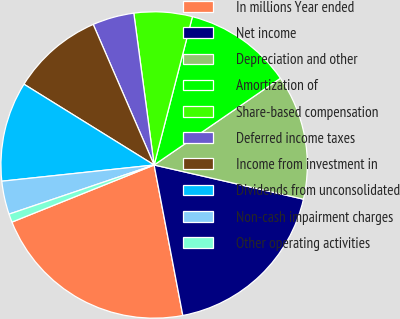Convert chart. <chart><loc_0><loc_0><loc_500><loc_500><pie_chart><fcel>In millions Year ended<fcel>Net income<fcel>Depreciation and other<fcel>Amortization of<fcel>Share-based compensation<fcel>Deferred income taxes<fcel>Income from investment in<fcel>Dividends from unconsolidated<fcel>Non-cash impairment charges<fcel>Other operating activities<nl><fcel>21.92%<fcel>18.42%<fcel>13.16%<fcel>11.4%<fcel>6.14%<fcel>4.39%<fcel>9.65%<fcel>10.53%<fcel>3.51%<fcel>0.88%<nl></chart> 